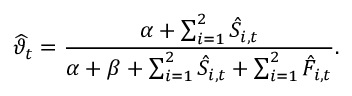Convert formula to latex. <formula><loc_0><loc_0><loc_500><loc_500>\widehat { \vartheta } _ { t } = \frac { \alpha + \sum _ { i = 1 } ^ { 2 } \hat { S } _ { i , t } } { \alpha + \beta + \sum _ { i = 1 } ^ { 2 } \hat { S } _ { i , t } + \sum _ { i = 1 } ^ { 2 } \hat { F } _ { i , t } } .</formula> 